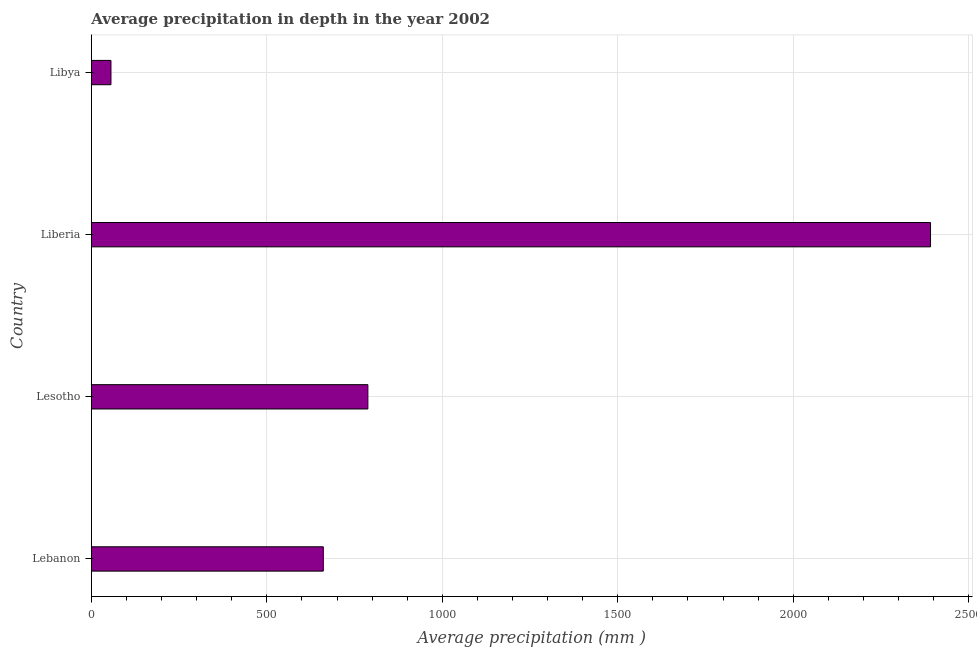What is the title of the graph?
Give a very brief answer. Average precipitation in depth in the year 2002. What is the label or title of the X-axis?
Provide a short and direct response. Average precipitation (mm ). What is the label or title of the Y-axis?
Your answer should be compact. Country. What is the average precipitation in depth in Lebanon?
Your answer should be very brief. 661. Across all countries, what is the maximum average precipitation in depth?
Offer a terse response. 2391. Across all countries, what is the minimum average precipitation in depth?
Ensure brevity in your answer.  56. In which country was the average precipitation in depth maximum?
Keep it short and to the point. Liberia. In which country was the average precipitation in depth minimum?
Give a very brief answer. Libya. What is the sum of the average precipitation in depth?
Provide a short and direct response. 3896. What is the difference between the average precipitation in depth in Liberia and Libya?
Your response must be concise. 2335. What is the average average precipitation in depth per country?
Offer a terse response. 974. What is the median average precipitation in depth?
Your answer should be very brief. 724.5. What is the ratio of the average precipitation in depth in Lesotho to that in Libya?
Offer a very short reply. 14.07. Is the average precipitation in depth in Lebanon less than that in Libya?
Ensure brevity in your answer.  No. Is the difference between the average precipitation in depth in Lesotho and Liberia greater than the difference between any two countries?
Make the answer very short. No. What is the difference between the highest and the second highest average precipitation in depth?
Offer a very short reply. 1603. Is the sum of the average precipitation in depth in Lebanon and Lesotho greater than the maximum average precipitation in depth across all countries?
Offer a terse response. No. What is the difference between the highest and the lowest average precipitation in depth?
Give a very brief answer. 2335. How many bars are there?
Keep it short and to the point. 4. How many countries are there in the graph?
Give a very brief answer. 4. Are the values on the major ticks of X-axis written in scientific E-notation?
Provide a short and direct response. No. What is the Average precipitation (mm ) of Lebanon?
Your answer should be compact. 661. What is the Average precipitation (mm ) in Lesotho?
Give a very brief answer. 788. What is the Average precipitation (mm ) in Liberia?
Provide a succinct answer. 2391. What is the difference between the Average precipitation (mm ) in Lebanon and Lesotho?
Provide a short and direct response. -127. What is the difference between the Average precipitation (mm ) in Lebanon and Liberia?
Provide a succinct answer. -1730. What is the difference between the Average precipitation (mm ) in Lebanon and Libya?
Your answer should be very brief. 605. What is the difference between the Average precipitation (mm ) in Lesotho and Liberia?
Provide a succinct answer. -1603. What is the difference between the Average precipitation (mm ) in Lesotho and Libya?
Give a very brief answer. 732. What is the difference between the Average precipitation (mm ) in Liberia and Libya?
Your answer should be compact. 2335. What is the ratio of the Average precipitation (mm ) in Lebanon to that in Lesotho?
Make the answer very short. 0.84. What is the ratio of the Average precipitation (mm ) in Lebanon to that in Liberia?
Keep it short and to the point. 0.28. What is the ratio of the Average precipitation (mm ) in Lebanon to that in Libya?
Provide a short and direct response. 11.8. What is the ratio of the Average precipitation (mm ) in Lesotho to that in Liberia?
Offer a very short reply. 0.33. What is the ratio of the Average precipitation (mm ) in Lesotho to that in Libya?
Give a very brief answer. 14.07. What is the ratio of the Average precipitation (mm ) in Liberia to that in Libya?
Keep it short and to the point. 42.7. 